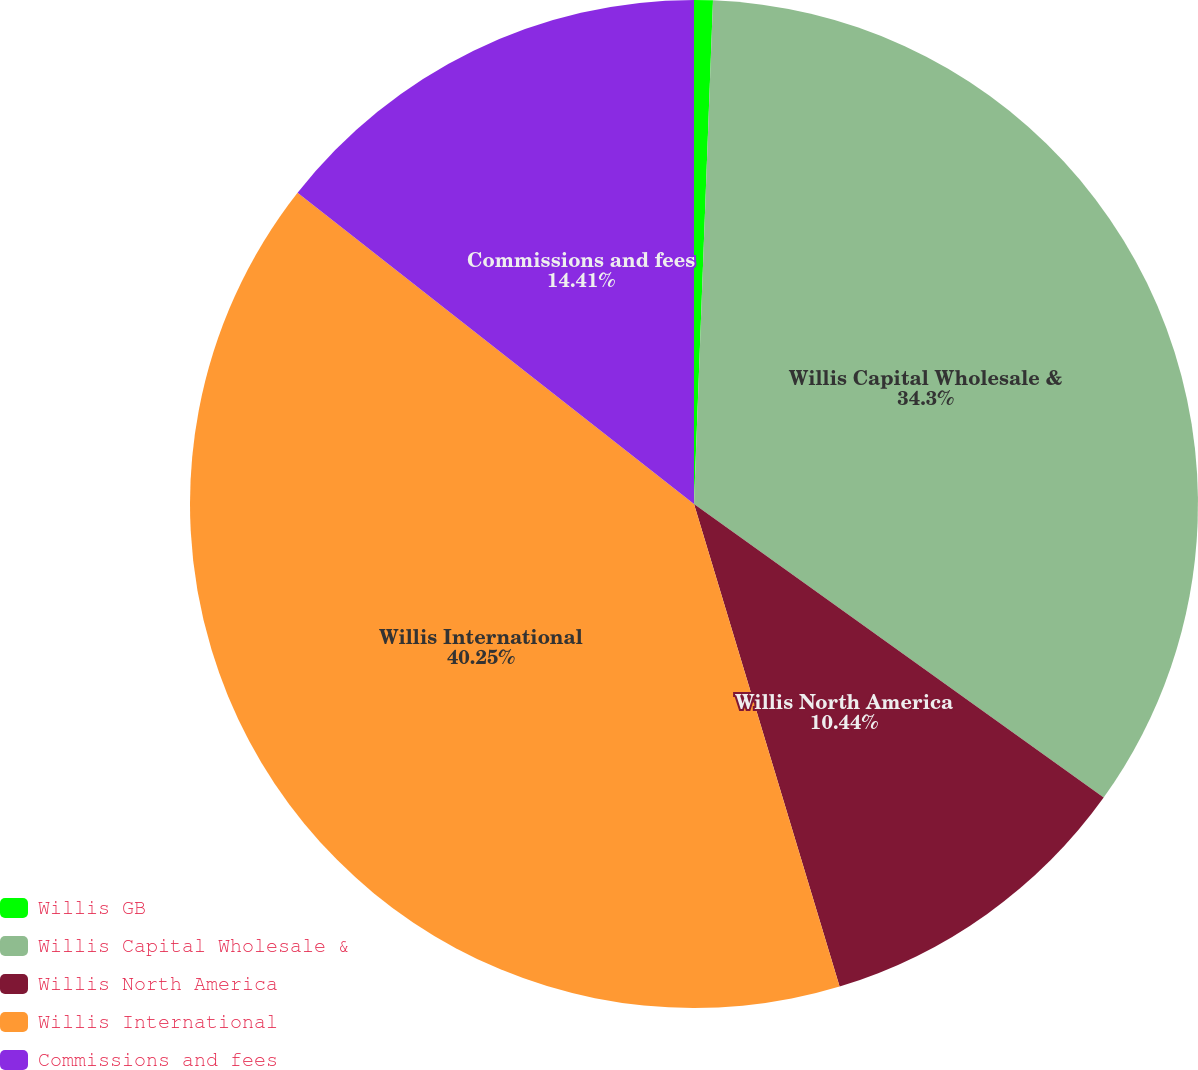Convert chart. <chart><loc_0><loc_0><loc_500><loc_500><pie_chart><fcel>Willis GB<fcel>Willis Capital Wholesale &<fcel>Willis North America<fcel>Willis International<fcel>Commissions and fees<nl><fcel>0.6%<fcel>34.3%<fcel>10.44%<fcel>40.26%<fcel>14.41%<nl></chart> 